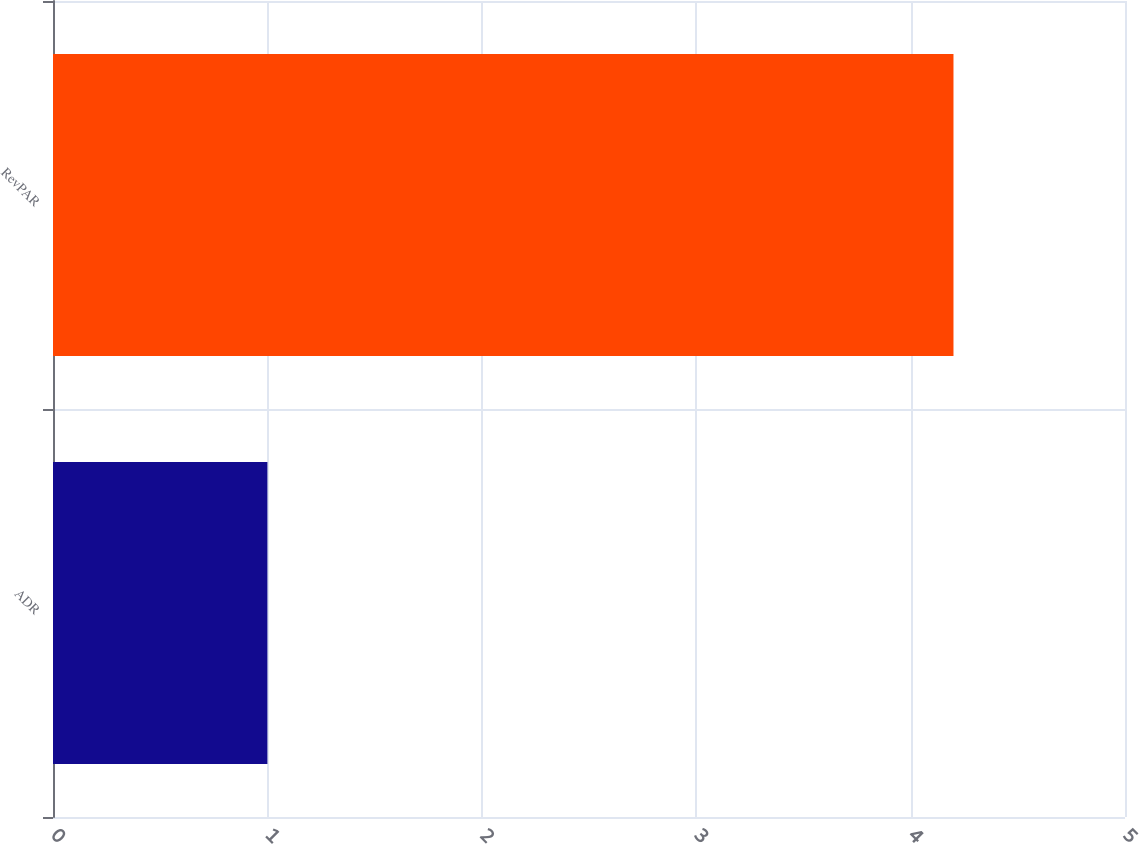<chart> <loc_0><loc_0><loc_500><loc_500><bar_chart><fcel>ADR<fcel>RevPAR<nl><fcel>1<fcel>4.2<nl></chart> 